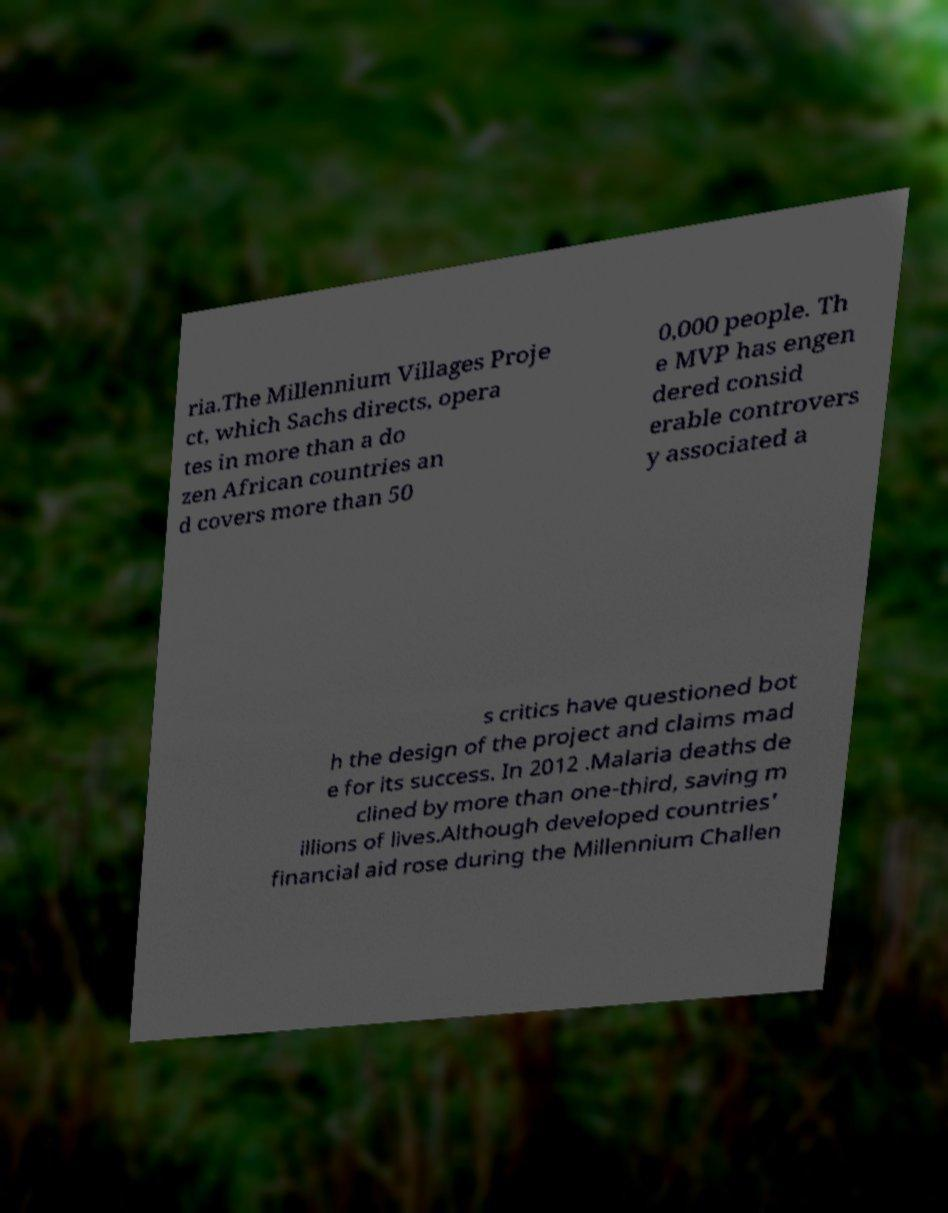Could you extract and type out the text from this image? ria.The Millennium Villages Proje ct, which Sachs directs, opera tes in more than a do zen African countries an d covers more than 50 0,000 people. Th e MVP has engen dered consid erable controvers y associated a s critics have questioned bot h the design of the project and claims mad e for its success. In 2012 .Malaria deaths de clined by more than one-third, saving m illions of lives.Although developed countries' financial aid rose during the Millennium Challen 